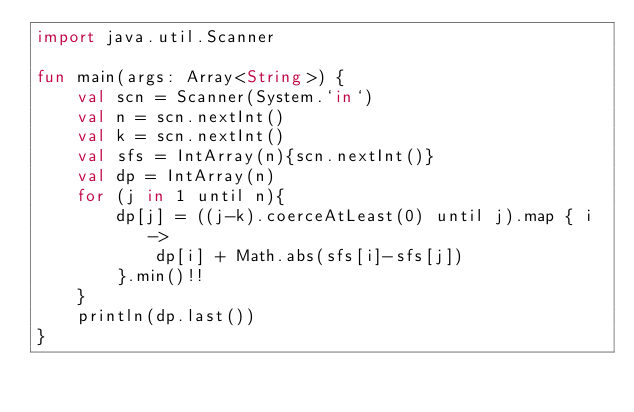<code> <loc_0><loc_0><loc_500><loc_500><_Kotlin_>import java.util.Scanner

fun main(args: Array<String>) {
	val scn = Scanner(System.`in`)
	val n = scn.nextInt()
	val k = scn.nextInt()
	val sfs = IntArray(n){scn.nextInt()}
	val dp = IntArray(n)
	for (j in 1 until n){
		dp[j] = ((j-k).coerceAtLeast(0) until j).map { i ->
			dp[i] + Math.abs(sfs[i]-sfs[j])
		}.min()!!
	}
	println(dp.last())
}</code> 